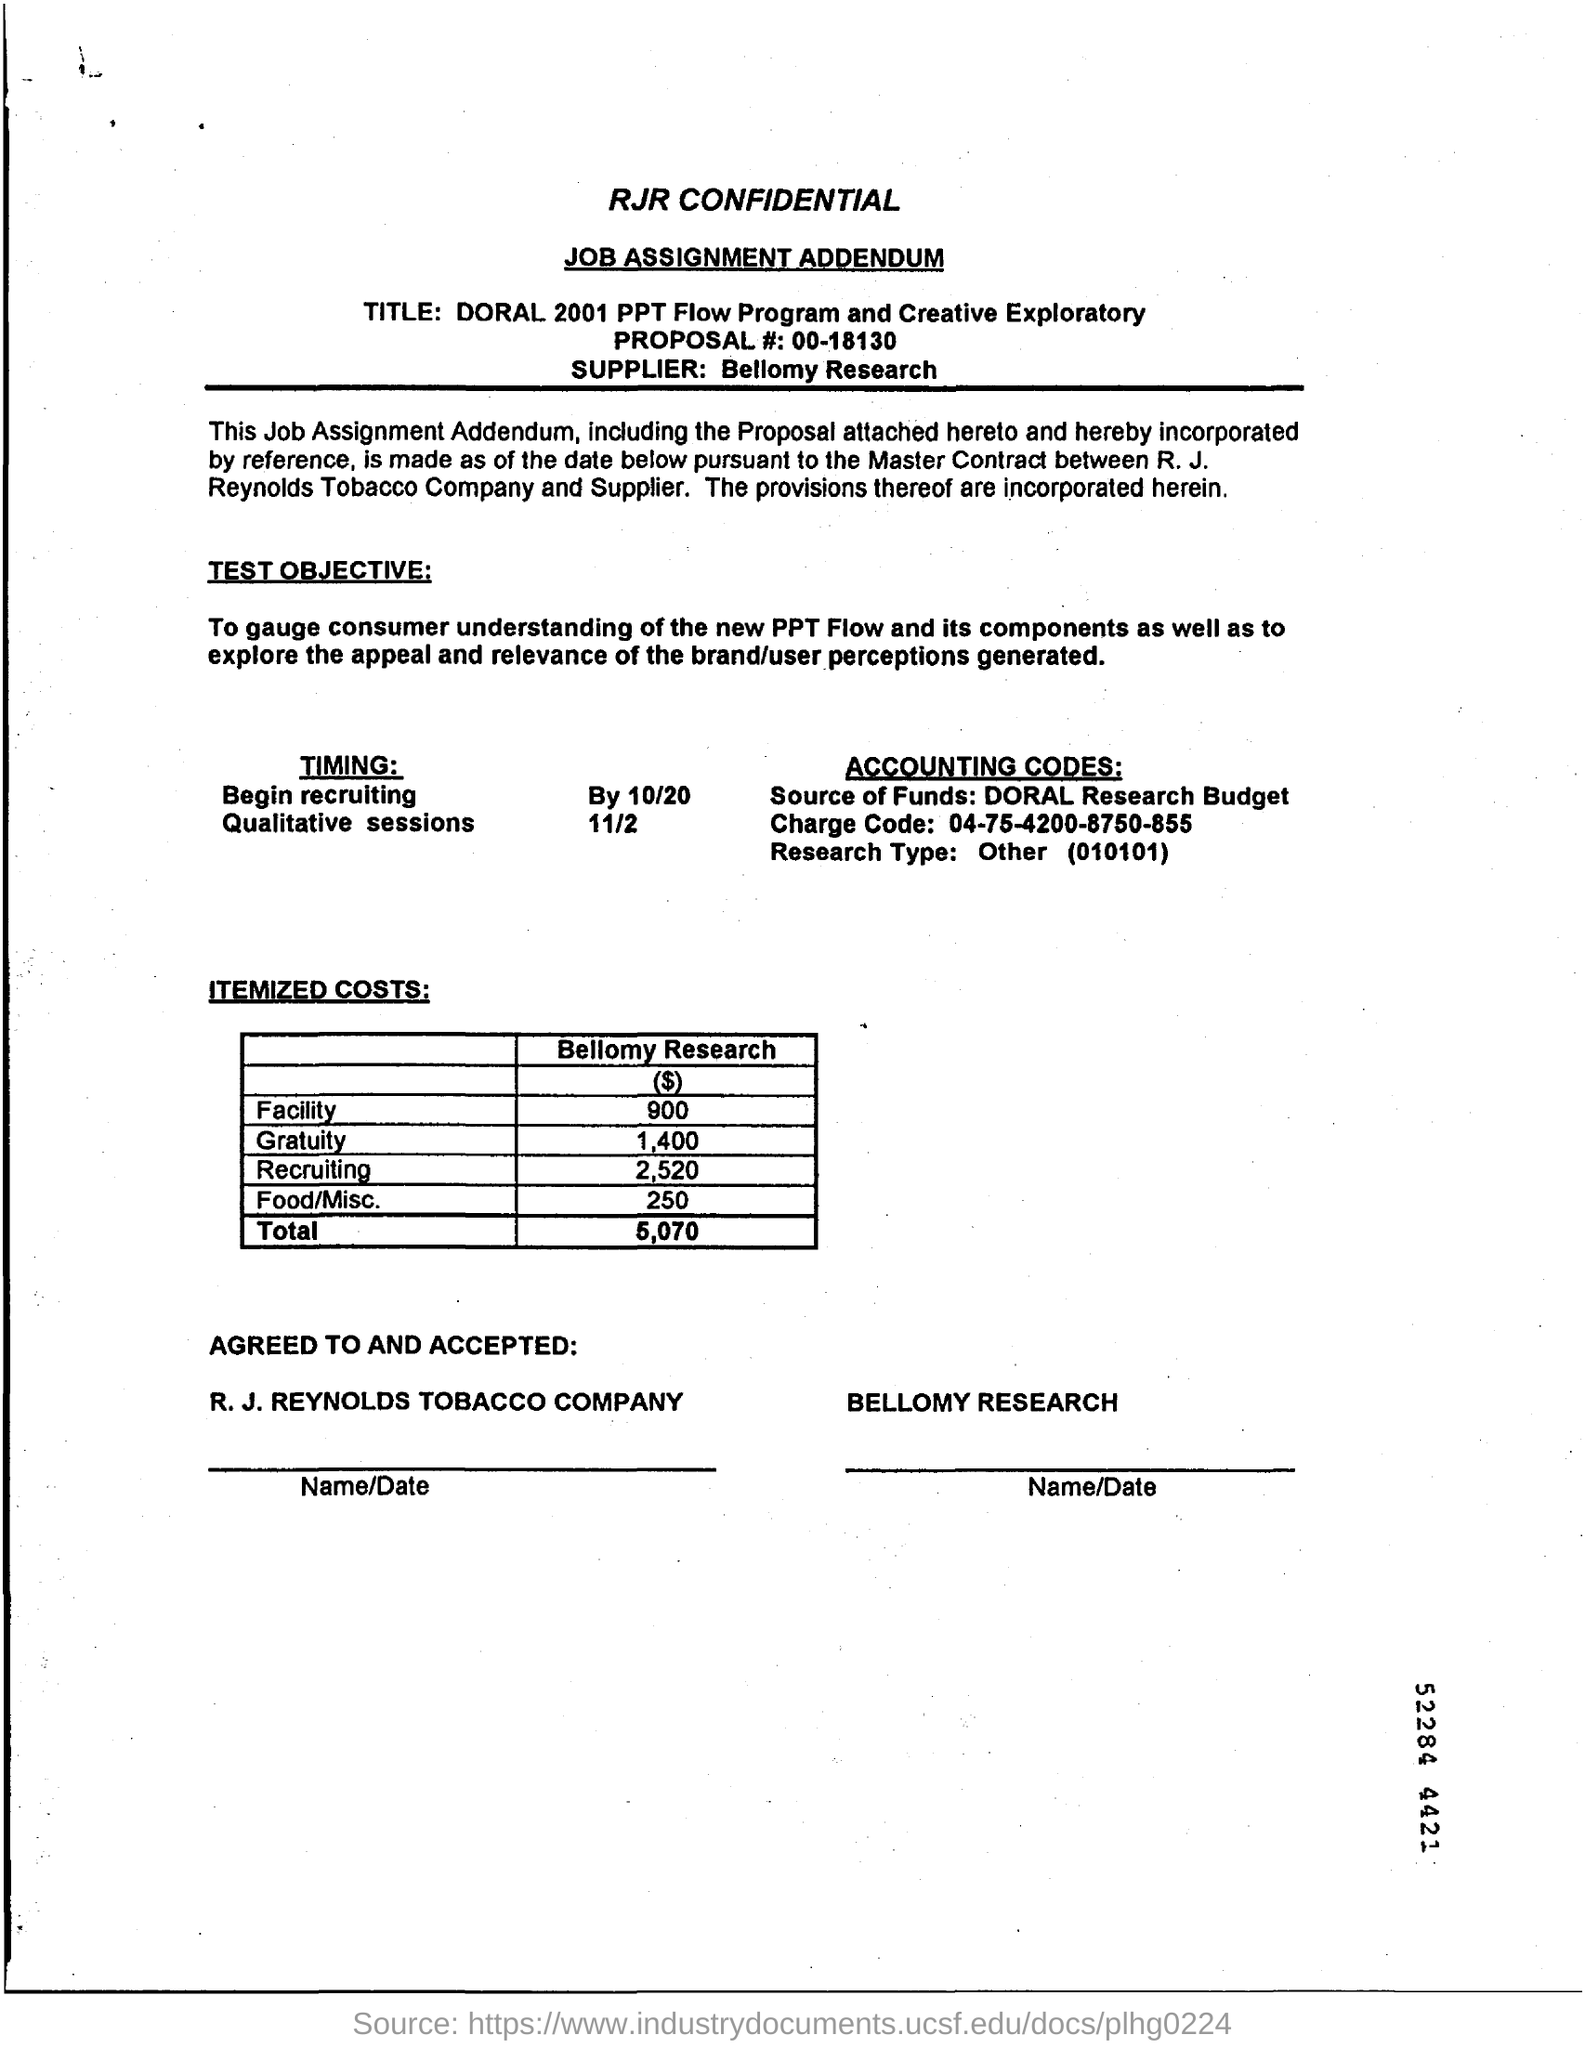Who is the supplier?
Provide a short and direct response. Bellomy Research. What is the itemized costs "Total" ?
Provide a succinct answer. 5,070. What is the timing for Qualitative sessions?
Ensure brevity in your answer.  11/2. 